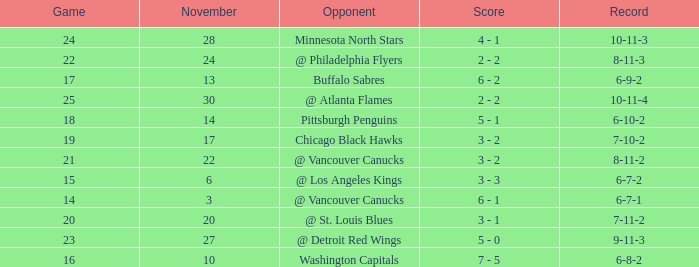What is the game when on november 27? 23.0. Could you parse the entire table as a dict? {'header': ['Game', 'November', 'Opponent', 'Score', 'Record'], 'rows': [['24', '28', 'Minnesota North Stars', '4 - 1', '10-11-3'], ['22', '24', '@ Philadelphia Flyers', '2 - 2', '8-11-3'], ['17', '13', 'Buffalo Sabres', '6 - 2', '6-9-2'], ['25', '30', '@ Atlanta Flames', '2 - 2', '10-11-4'], ['18', '14', 'Pittsburgh Penguins', '5 - 1', '6-10-2'], ['19', '17', 'Chicago Black Hawks', '3 - 2', '7-10-2'], ['21', '22', '@ Vancouver Canucks', '3 - 2', '8-11-2'], ['15', '6', '@ Los Angeles Kings', '3 - 3', '6-7-2'], ['14', '3', '@ Vancouver Canucks', '6 - 1', '6-7-1'], ['20', '20', '@ St. Louis Blues', '3 - 1', '7-11-2'], ['23', '27', '@ Detroit Red Wings', '5 - 0', '9-11-3'], ['16', '10', 'Washington Capitals', '7 - 5', '6-8-2']]} 